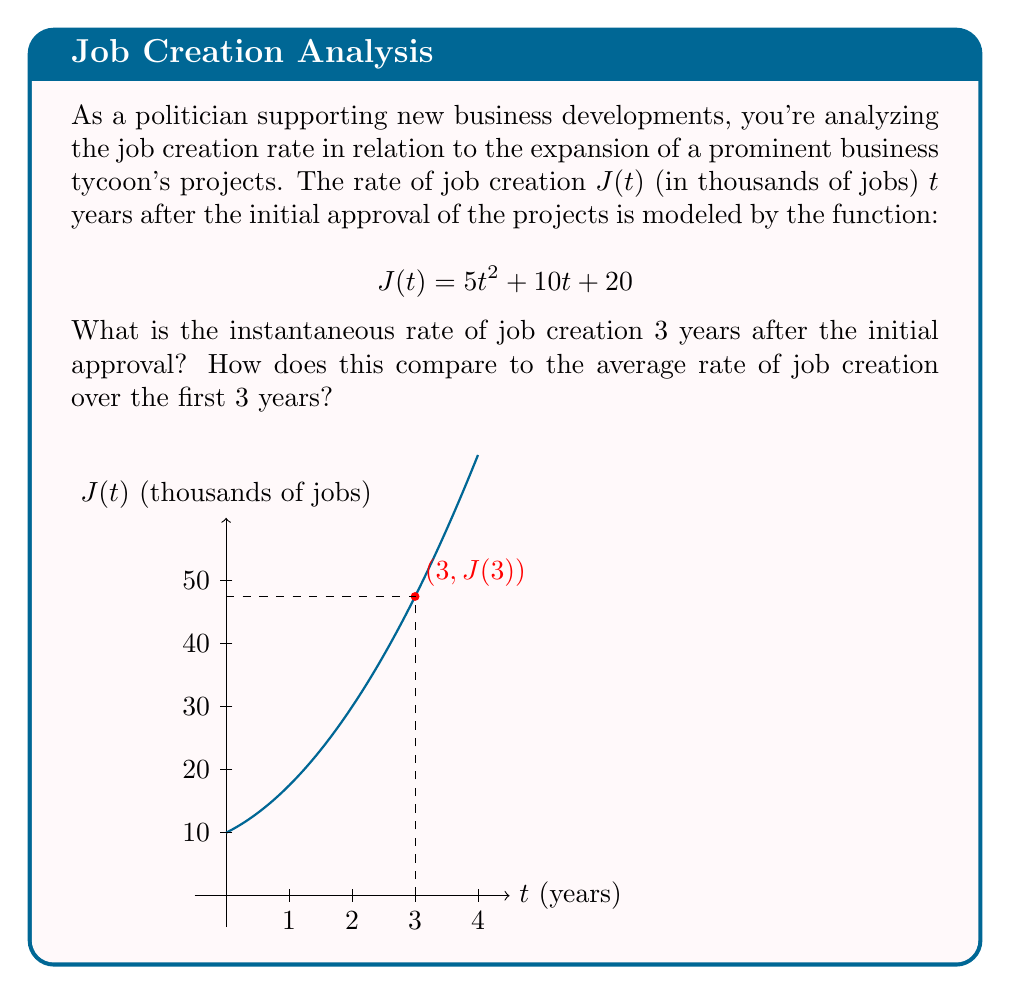Give your solution to this math problem. To solve this problem, we'll follow these steps:

1) First, let's find the instantaneous rate of job creation at $t=3$ years. This is given by the derivative of $J(t)$ evaluated at $t=3$.

   $$J'(t) = \frac{d}{dt}(5t^2 + 10t + 20) = 10t + 10$$

   At $t=3$:
   $$J'(3) = 10(3) + 10 = 40$$

2) Now, let's calculate the average rate of job creation over the first 3 years. This is given by the difference quotient:

   $$\text{Average rate} = \frac{J(3) - J(0)}{3 - 0}$$

3) Calculate $J(3)$ and $J(0)$:
   
   $$J(3) = 5(3)^2 + 10(3) + 20 = 45 + 30 + 20 = 95$$
   $$J(0) = 5(0)^2 + 10(0) + 20 = 20$$

4) Now we can compute the average rate:

   $$\text{Average rate} = \frac{95 - 20}{3} = 25$$

5) Comparing the two rates:
   - Instantaneous rate at $t=3$: 40 thousand jobs per year
   - Average rate over first 3 years: 25 thousand jobs per year

   The instantaneous rate is higher, indicating accelerating job growth.
Answer: Instantaneous rate: 40 thousand jobs/year; Average rate: 25 thousand jobs/year 